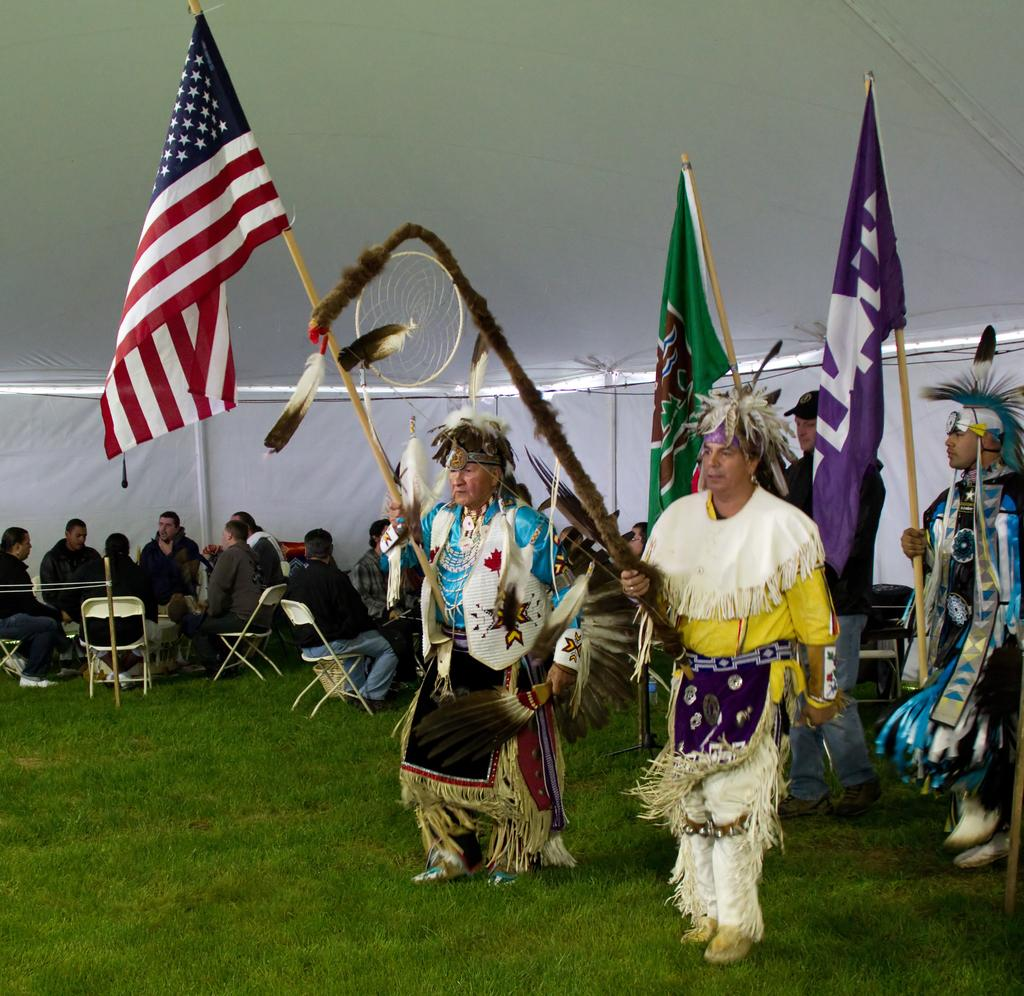How many people are in the foreground of the picture? There are four people in the foreground of the picture. What are the people in the foreground holding? The people in the foreground are holding flags. What type of ground surface is visible in the foreground of the picture? There is grass in the foreground of the picture. What can be seen in the background of the picture? There are people and chairs in the background of the picture. Is there any shelter visible in the image? Yes, there is a tent visible at the top of the image. What type of planes are flying over the people in the image? There are no planes visible in the image. What is the purpose of the people holding flags in the image? The purpose of the people holding flags cannot be determined from the image alone. 